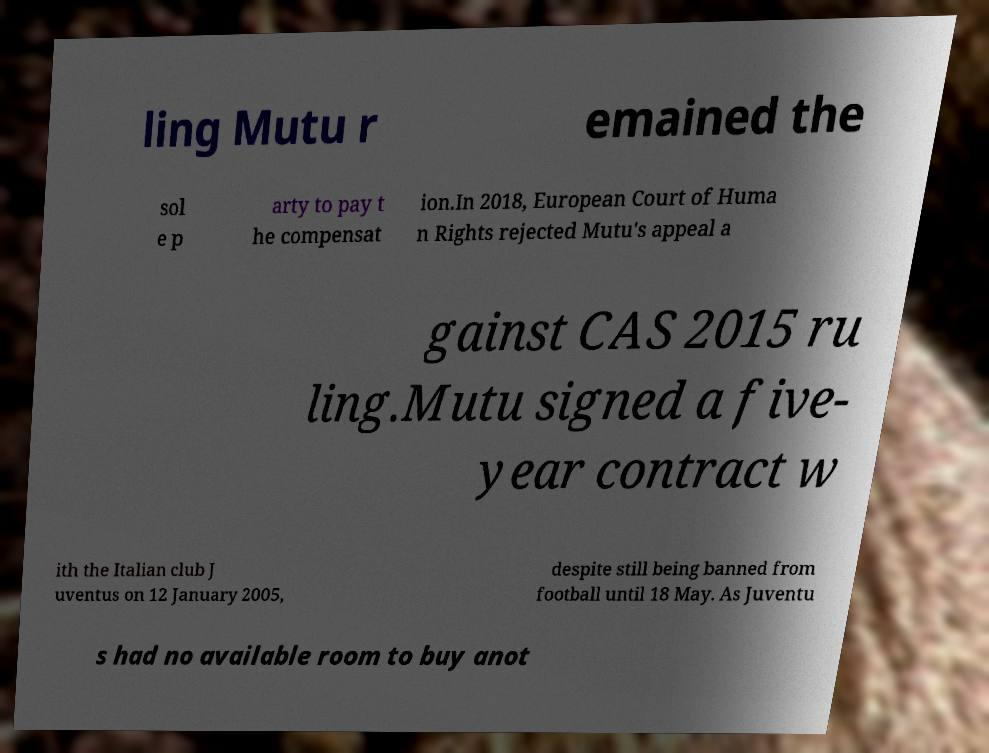Please identify and transcribe the text found in this image. ling Mutu r emained the sol e p arty to pay t he compensat ion.In 2018, European Court of Huma n Rights rejected Mutu's appeal a gainst CAS 2015 ru ling.Mutu signed a five- year contract w ith the Italian club J uventus on 12 January 2005, despite still being banned from football until 18 May. As Juventu s had no available room to buy anot 